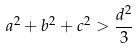<formula> <loc_0><loc_0><loc_500><loc_500>a ^ { 2 } + b ^ { 2 } + c ^ { 2 } > \frac { d ^ { 2 } } { 3 }</formula> 